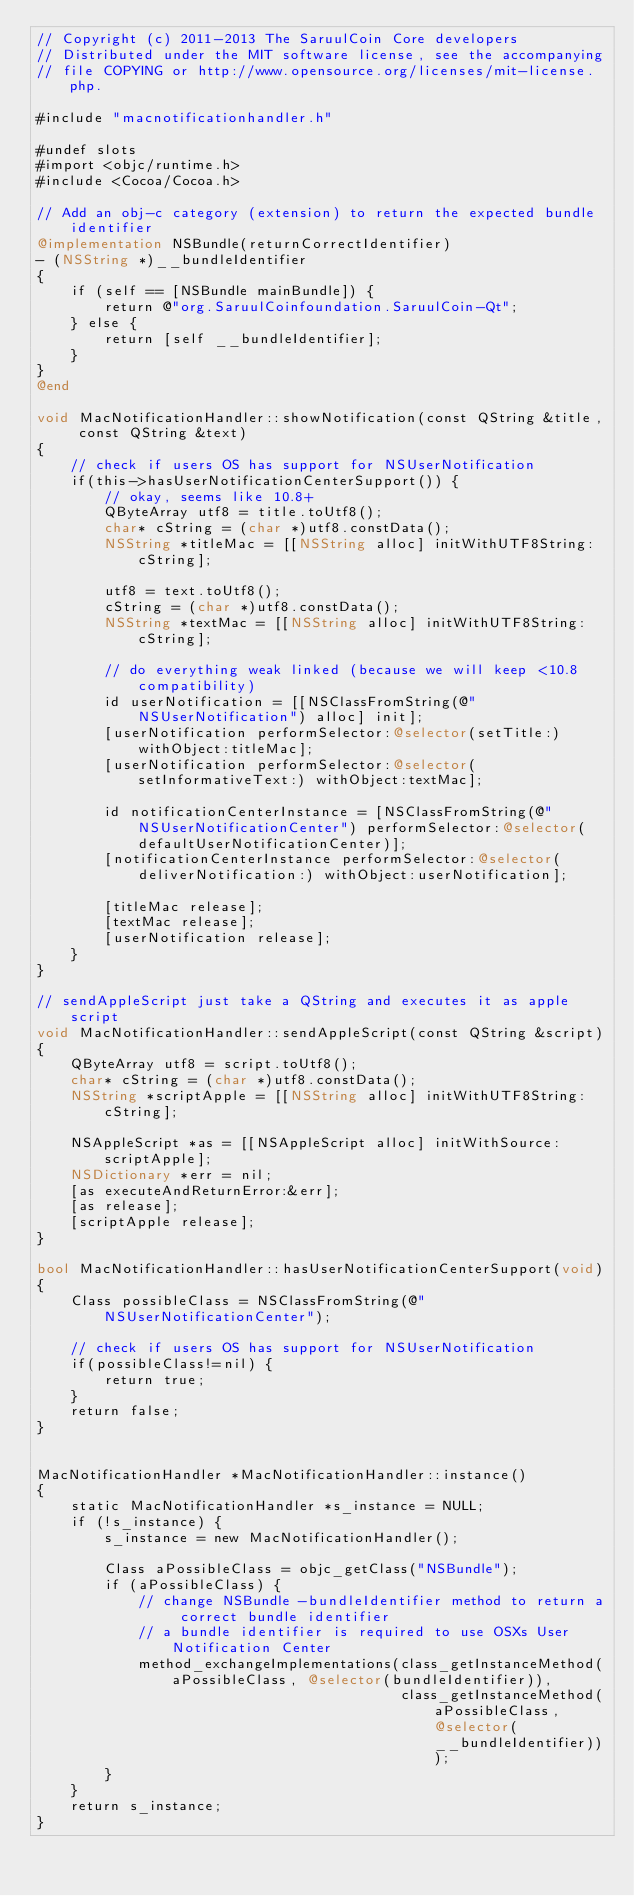Convert code to text. <code><loc_0><loc_0><loc_500><loc_500><_ObjectiveC_>// Copyright (c) 2011-2013 The SaruulCoin Core developers
// Distributed under the MIT software license, see the accompanying
// file COPYING or http://www.opensource.org/licenses/mit-license.php.

#include "macnotificationhandler.h"

#undef slots
#import <objc/runtime.h>
#include <Cocoa/Cocoa.h>

// Add an obj-c category (extension) to return the expected bundle identifier
@implementation NSBundle(returnCorrectIdentifier)
- (NSString *)__bundleIdentifier
{
    if (self == [NSBundle mainBundle]) {
        return @"org.SaruulCoinfoundation.SaruulCoin-Qt";
    } else {
        return [self __bundleIdentifier];
    }
}
@end

void MacNotificationHandler::showNotification(const QString &title, const QString &text)
{
    // check if users OS has support for NSUserNotification
    if(this->hasUserNotificationCenterSupport()) {
        // okay, seems like 10.8+
        QByteArray utf8 = title.toUtf8();
        char* cString = (char *)utf8.constData();
        NSString *titleMac = [[NSString alloc] initWithUTF8String:cString];

        utf8 = text.toUtf8();
        cString = (char *)utf8.constData();
        NSString *textMac = [[NSString alloc] initWithUTF8String:cString];

        // do everything weak linked (because we will keep <10.8 compatibility)
        id userNotification = [[NSClassFromString(@"NSUserNotification") alloc] init];
        [userNotification performSelector:@selector(setTitle:) withObject:titleMac];
        [userNotification performSelector:@selector(setInformativeText:) withObject:textMac];

        id notificationCenterInstance = [NSClassFromString(@"NSUserNotificationCenter") performSelector:@selector(defaultUserNotificationCenter)];
        [notificationCenterInstance performSelector:@selector(deliverNotification:) withObject:userNotification];

        [titleMac release];
        [textMac release];
        [userNotification release];
    }
}

// sendAppleScript just take a QString and executes it as apple script
void MacNotificationHandler::sendAppleScript(const QString &script)
{
    QByteArray utf8 = script.toUtf8();
    char* cString = (char *)utf8.constData();
    NSString *scriptApple = [[NSString alloc] initWithUTF8String:cString];

    NSAppleScript *as = [[NSAppleScript alloc] initWithSource:scriptApple];
    NSDictionary *err = nil;
    [as executeAndReturnError:&err];
    [as release];
    [scriptApple release];
}

bool MacNotificationHandler::hasUserNotificationCenterSupport(void)
{
    Class possibleClass = NSClassFromString(@"NSUserNotificationCenter");

    // check if users OS has support for NSUserNotification
    if(possibleClass!=nil) {
        return true;
    }
    return false;
}


MacNotificationHandler *MacNotificationHandler::instance()
{
    static MacNotificationHandler *s_instance = NULL;
    if (!s_instance) {
        s_instance = new MacNotificationHandler();
        
        Class aPossibleClass = objc_getClass("NSBundle");
        if (aPossibleClass) {
            // change NSBundle -bundleIdentifier method to return a correct bundle identifier
            // a bundle identifier is required to use OSXs User Notification Center
            method_exchangeImplementations(class_getInstanceMethod(aPossibleClass, @selector(bundleIdentifier)),
                                           class_getInstanceMethod(aPossibleClass, @selector(__bundleIdentifier)));
        }
    }
    return s_instance;
}
</code> 